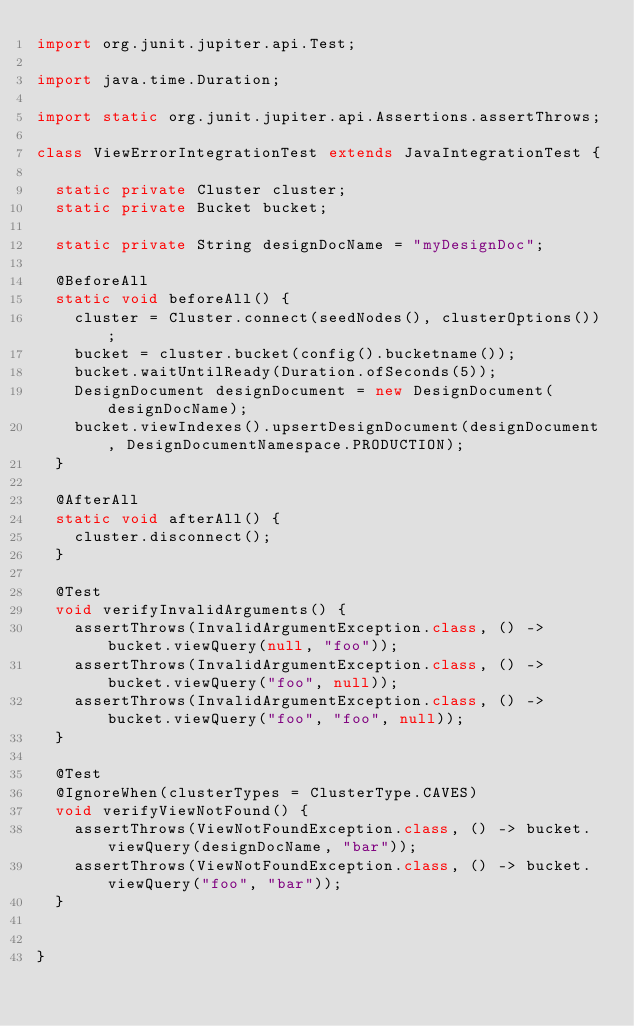Convert code to text. <code><loc_0><loc_0><loc_500><loc_500><_Java_>import org.junit.jupiter.api.Test;

import java.time.Duration;

import static org.junit.jupiter.api.Assertions.assertThrows;

class ViewErrorIntegrationTest extends JavaIntegrationTest {

  static private Cluster cluster;
  static private Bucket bucket;

  static private String designDocName = "myDesignDoc";

  @BeforeAll
  static void beforeAll() {
    cluster = Cluster.connect(seedNodes(), clusterOptions());
    bucket = cluster.bucket(config().bucketname());
    bucket.waitUntilReady(Duration.ofSeconds(5));
    DesignDocument designDocument = new DesignDocument(designDocName);
    bucket.viewIndexes().upsertDesignDocument(designDocument, DesignDocumentNamespace.PRODUCTION);
  }

  @AfterAll
  static void afterAll() {
    cluster.disconnect();
  }

  @Test
  void verifyInvalidArguments() {
    assertThrows(InvalidArgumentException.class, () -> bucket.viewQuery(null, "foo"));
    assertThrows(InvalidArgumentException.class, () -> bucket.viewQuery("foo", null));
    assertThrows(InvalidArgumentException.class, () -> bucket.viewQuery("foo", "foo", null));
  }

  @Test
  @IgnoreWhen(clusterTypes = ClusterType.CAVES)
  void verifyViewNotFound() {
    assertThrows(ViewNotFoundException.class, () -> bucket.viewQuery(designDocName, "bar"));
    assertThrows(ViewNotFoundException.class, () -> bucket.viewQuery("foo", "bar"));
  }


}
</code> 